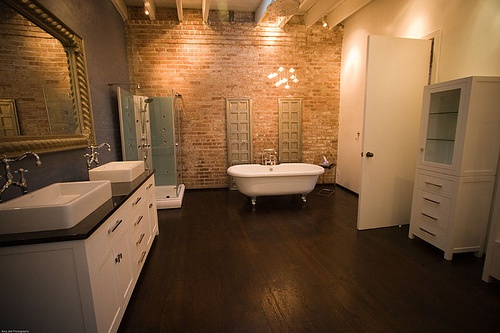Describe the objects in this image and their specific colors. I can see sink in black, gray, tan, and maroon tones and sink in black, tan, and gray tones in this image. 